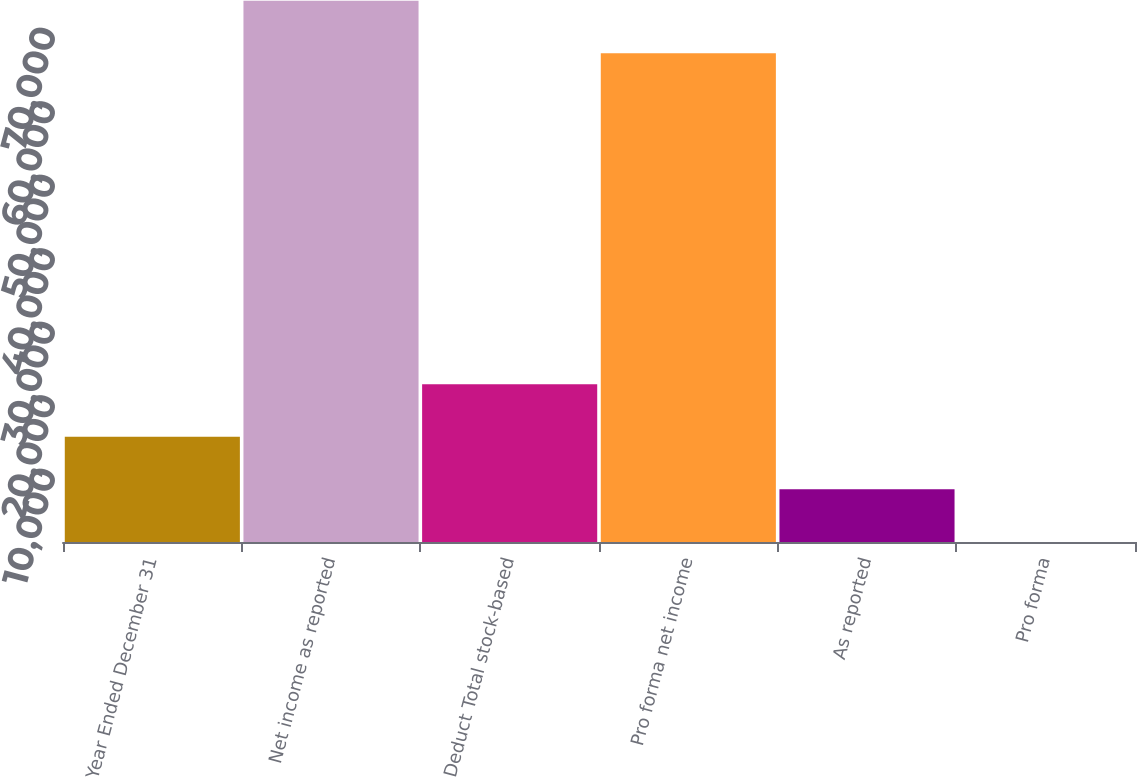Convert chart to OTSL. <chart><loc_0><loc_0><loc_500><loc_500><bar_chart><fcel>Year Ended December 31<fcel>Net income as reported<fcel>Deduct Total stock-based<fcel>Pro forma net income<fcel>As reported<fcel>Pro forma<nl><fcel>14320.1<fcel>73652.4<fcel>21479.5<fcel>66493<fcel>7160.79<fcel>1.43<nl></chart> 